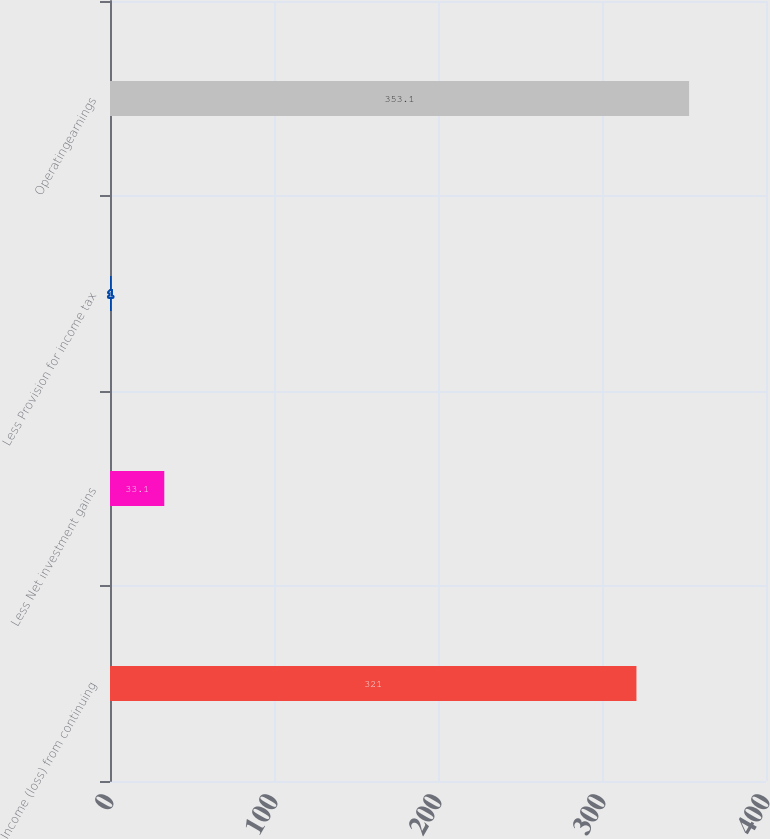Convert chart to OTSL. <chart><loc_0><loc_0><loc_500><loc_500><bar_chart><fcel>Income (loss) from continuing<fcel>Less Net investment gains<fcel>Less Provision for income tax<fcel>Operatingearnings<nl><fcel>321<fcel>33.1<fcel>1<fcel>353.1<nl></chart> 